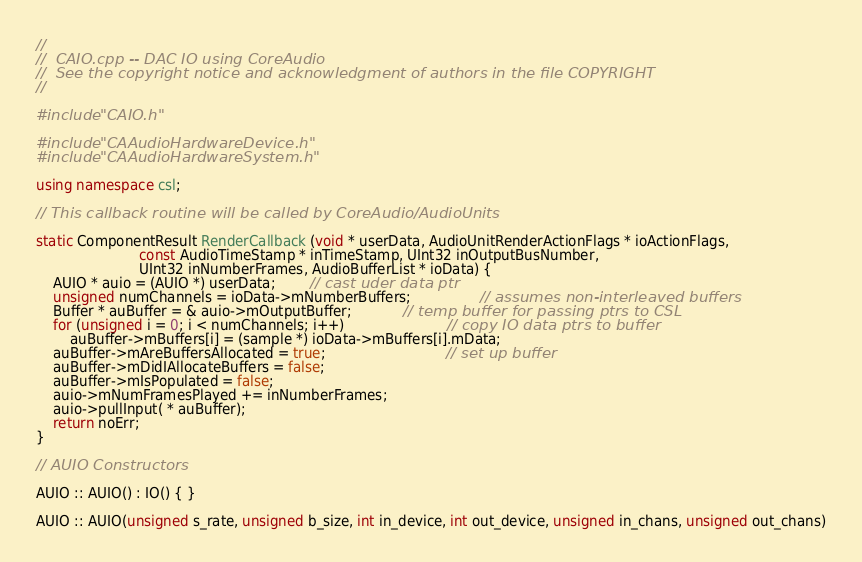Convert code to text. <code><loc_0><loc_0><loc_500><loc_500><_C++_>//
//  CAIO.cpp -- DAC IO using CoreAudio
//	See the copyright notice and acknowledgment of authors in the file COPYRIGHT
//

#include "CAIO.h"

#include "CAAudioHardwareDevice.h"
#include "CAAudioHardwareSystem.h"

using namespace csl;

// This callback routine will be called by CoreAudio/AudioUnits

static ComponentResult RenderCallback (void * userData, AudioUnitRenderActionFlags * ioActionFlags, 
						const AudioTimeStamp * inTimeStamp, UInt32 inOutputBusNumber, 
						UInt32 inNumberFrames, AudioBufferList * ioData) {
	AUIO * auio = (AUIO *) userData;		// cast uder data ptr
	unsigned numChannels = ioData->mNumberBuffers;				// assumes non-interleaved buffers
	Buffer * auBuffer = & auio->mOutputBuffer;			// temp buffer for passing ptrs to CSL
	for (unsigned i = 0; i < numChannels; i++)						// copy IO data ptrs to buffer
		auBuffer->mBuffers[i] = (sample *) ioData->mBuffers[i].mData;
	auBuffer->mAreBuffersAllocated = true;							// set up buffer
	auBuffer->mDidIAllocateBuffers = false;
	auBuffer->mIsPopulated = false;
	auio->mNumFramesPlayed += inNumberFrames;
	auio->pullInput( * auBuffer);
	return noErr;	
}

// AUIO Constructors

AUIO :: AUIO() : IO() { }

AUIO :: AUIO(unsigned s_rate, unsigned b_size, int in_device, int out_device, unsigned in_chans, unsigned out_chans)</code> 